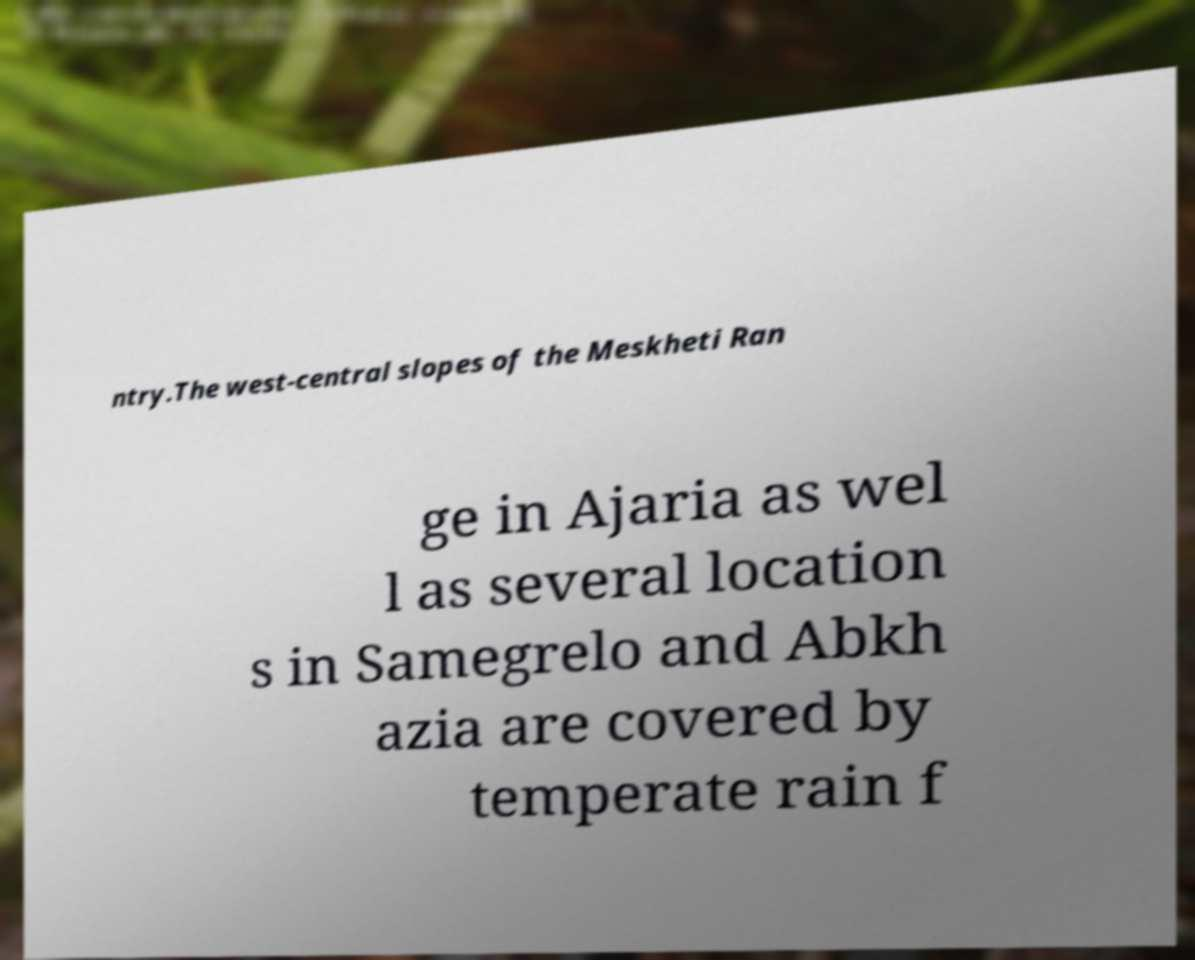I need the written content from this picture converted into text. Can you do that? ntry.The west-central slopes of the Meskheti Ran ge in Ajaria as wel l as several location s in Samegrelo and Abkh azia are covered by temperate rain f 